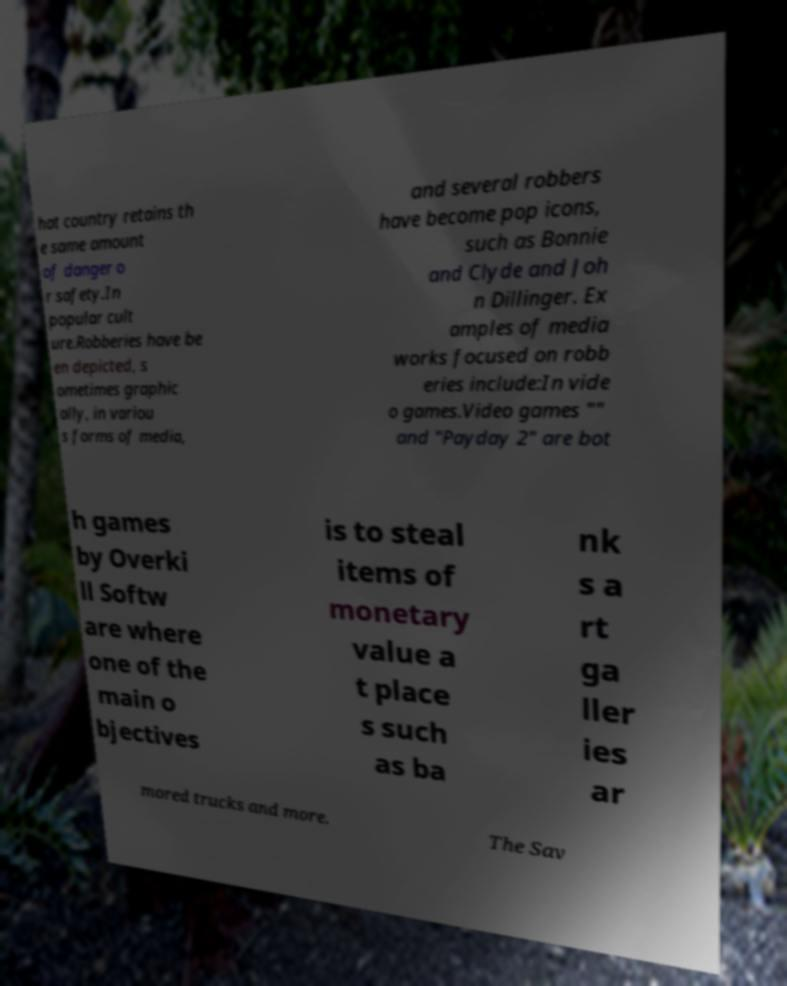There's text embedded in this image that I need extracted. Can you transcribe it verbatim? hat country retains th e same amount of danger o r safety.In popular cult ure.Robberies have be en depicted, s ometimes graphic ally, in variou s forms of media, and several robbers have become pop icons, such as Bonnie and Clyde and Joh n Dillinger. Ex amples of media works focused on robb eries include:In vide o games.Video games "" and "Payday 2" are bot h games by Overki ll Softw are where one of the main o bjectives is to steal items of monetary value a t place s such as ba nk s a rt ga ller ies ar mored trucks and more. The Sav 